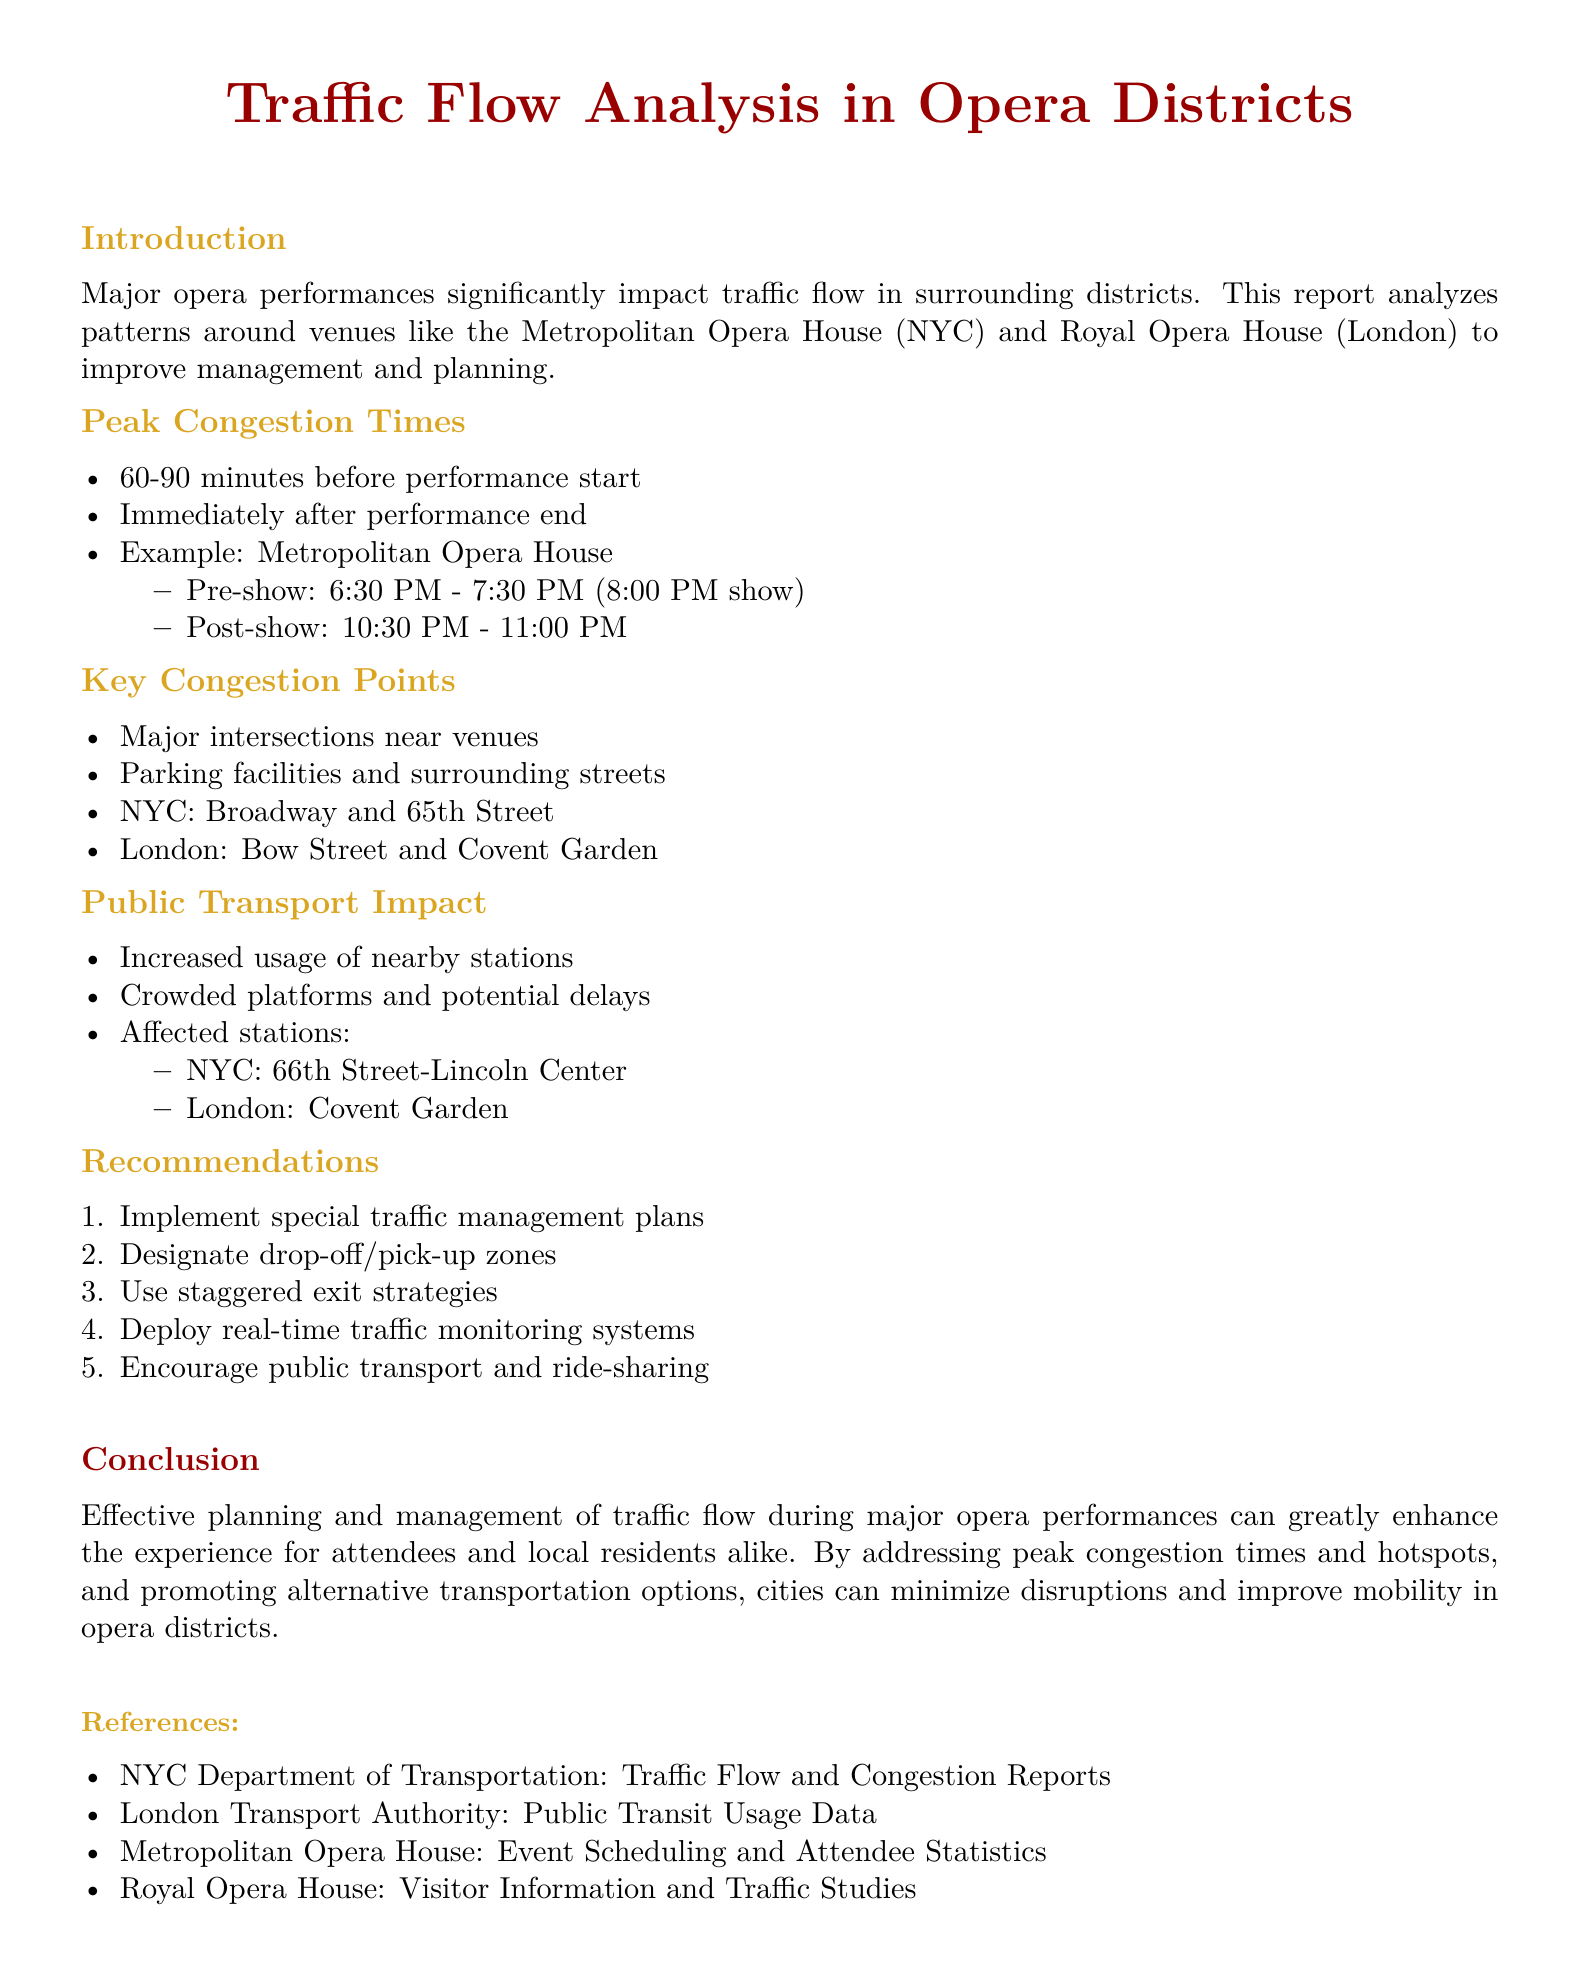what are the peak congestion times before a performance? The report specifies peak congestion times occurring 60-90 minutes before performance start.
Answer: 60-90 minutes before performance start what is a key congestion point in NYC? The document lists Broadway and 65th Street as a key congestion point in NYC.
Answer: Broadway and 65th Street when does the post-show congestion occur at the Metropolitan Opera House? According to the report, post-show congestion occurs from 10:30 PM to 11:00 PM.
Answer: 10:30 PM - 11:00 PM how many recommendations are provided in the report? The document outlines five recommendations for traffic management during performances.
Answer: five which public transport station is affected in London? The affected public transport station in London mentioned in the report is Covent Garden.
Answer: Covent Garden what is the purpose of the traffic report? The report aims to analyze traffic flow patterns during major opera performances for better management and planning.
Answer: improve management and planning what is the time range for pre-show congestion at the Royal Opera House? The report does not explicitly provide a time range for the Royal Opera House, only for the Metropolitan Opera House (which is 6:30 PM to 7:30 PM).
Answer: Not specified what color represents the title in the document? The title is represented in the color operared as defined in the document.
Answer: operared 